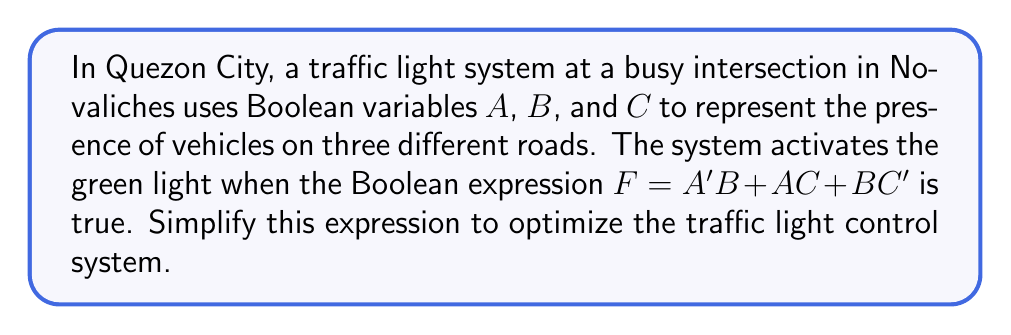Give your solution to this math problem. Let's simplify the Boolean expression $F = A'B + AC + BC'$ step by step:

1) First, we can use the distributive law to expand the expression:
   $F = A'B + AC + BC'$

2) Next, we can apply the consensus theorem, which states that for any Boolean expression of the form $XY + X'Z + YZ$, we can add the term $XZ$ without changing the function. In our case:
   $X = A$, $Y = C$, and $Z = B$
   So, we can add the term $AB$ to our expression:
   $F = A'B + AC + BC' + AB$

3) Now we can group the terms with $B$ and the terms with $C$:
   $F = (A'B + AB) + (AC + BC')$

4) In the first parenthesis, we can factor out $B$:
   $F = B(A' + A) + (AC + BC')$

5) $A' + A$ is always 1 in Boolean algebra (law of excluded middle), so:
   $F = B + (AC + BC')$

6) In the second parenthesis, we can factor out $C$:
   $F = B + C(A + B')$

7) The expression $A + B'$ cannot be simplified further.

Thus, the simplified expression is $F = B + C(A + B')$.
Answer: $F = B + C(A + B')$ 